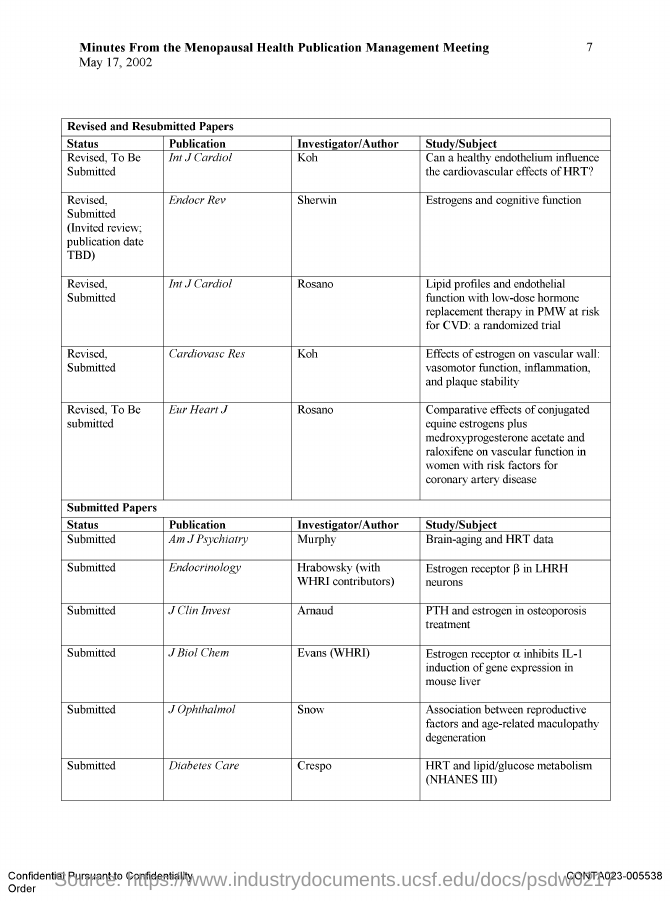Who is the Investigator/Author for publication in "Int J Cardiol" dealing with the study on endothelium?
Provide a short and direct response. Koh. Who is the Investigator/Author for publication "Endocr Rev"?
Make the answer very short. Sherwin. Who is the Investigator/Author for publication "Cardiovase Res"?
Your answer should be compact. Koh. Who is the Investigator/Author for publication "Eur Heart J"?
Offer a very short reply. Rosano. Who is the Investigator/Author for publication "Am J Psychiatry"?
Your response must be concise. Murphy. Who is the Investigator/Author for publication in "endocrinology"?
Your response must be concise. Hrabowsky(with WHRI Contributors). Who is the Investigator/Author for publication "J clin Invest"?
Your answer should be compact. Arnaud. Who is the Investigator/Author for publication in "J Biol Chem"?
Offer a very short reply. Evans (WHRI). Who is the Investigator/Author for publication "J Ophthalmol"?
Your response must be concise. Snow. Who is the Investigator/Author for publication "Diabetes Care"?
Make the answer very short. Crespo. 